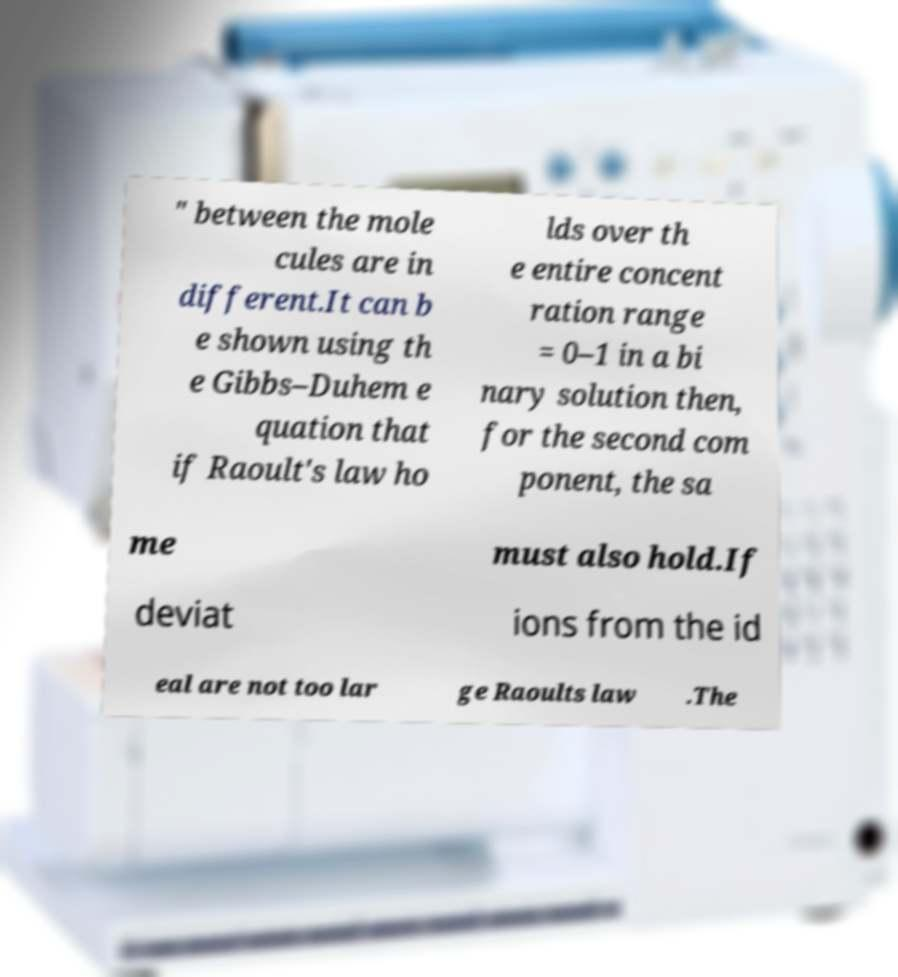For documentation purposes, I need the text within this image transcribed. Could you provide that? " between the mole cules are in different.It can b e shown using th e Gibbs–Duhem e quation that if Raoult's law ho lds over th e entire concent ration range = 0–1 in a bi nary solution then, for the second com ponent, the sa me must also hold.If deviat ions from the id eal are not too lar ge Raoults law .The 